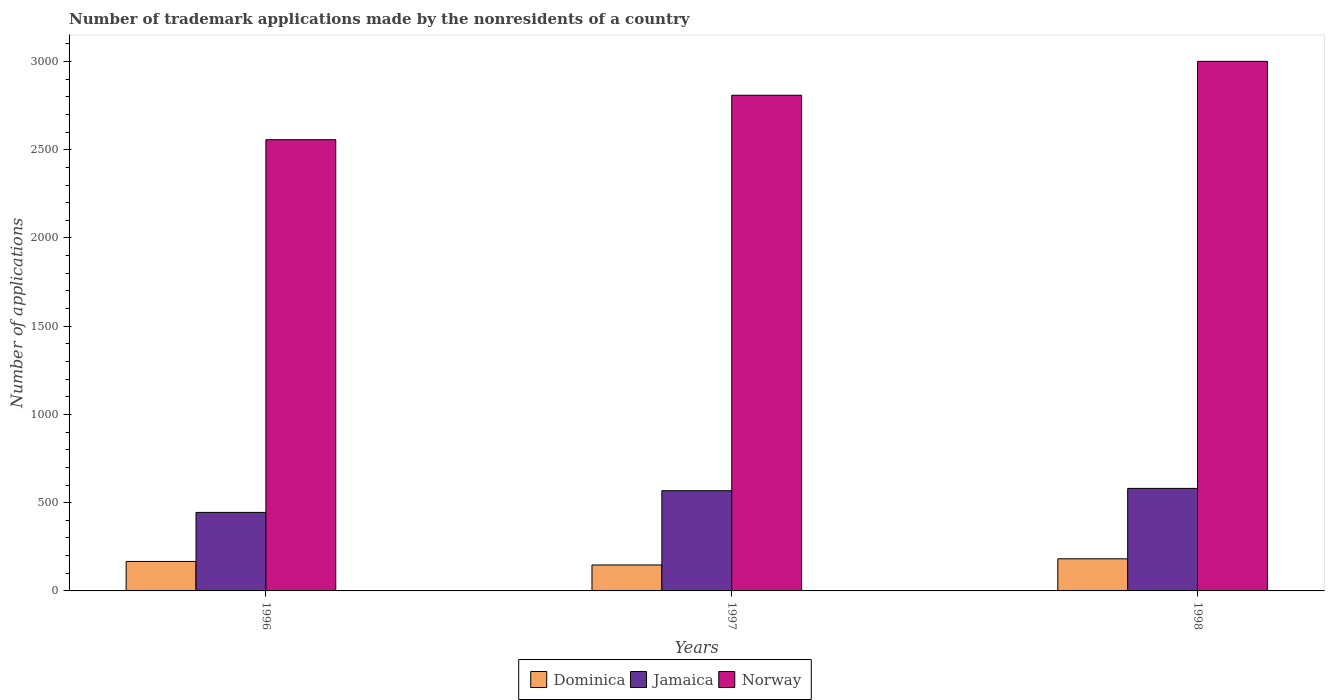How many different coloured bars are there?
Offer a terse response. 3. Are the number of bars on each tick of the X-axis equal?
Your answer should be very brief. Yes. How many bars are there on the 1st tick from the right?
Keep it short and to the point. 3. In how many cases, is the number of bars for a given year not equal to the number of legend labels?
Ensure brevity in your answer.  0. What is the number of trademark applications made by the nonresidents in Jamaica in 1996?
Offer a very short reply. 445. Across all years, what is the maximum number of trademark applications made by the nonresidents in Jamaica?
Your answer should be compact. 581. Across all years, what is the minimum number of trademark applications made by the nonresidents in Dominica?
Ensure brevity in your answer.  147. In which year was the number of trademark applications made by the nonresidents in Jamaica minimum?
Give a very brief answer. 1996. What is the total number of trademark applications made by the nonresidents in Norway in the graph?
Provide a short and direct response. 8367. What is the difference between the number of trademark applications made by the nonresidents in Norway in 1996 and that in 1997?
Offer a very short reply. -252. What is the difference between the number of trademark applications made by the nonresidents in Dominica in 1997 and the number of trademark applications made by the nonresidents in Jamaica in 1996?
Keep it short and to the point. -298. What is the average number of trademark applications made by the nonresidents in Jamaica per year?
Offer a very short reply. 531.33. In the year 1998, what is the difference between the number of trademark applications made by the nonresidents in Dominica and number of trademark applications made by the nonresidents in Jamaica?
Your answer should be compact. -399. In how many years, is the number of trademark applications made by the nonresidents in Jamaica greater than 2200?
Give a very brief answer. 0. What is the ratio of the number of trademark applications made by the nonresidents in Jamaica in 1996 to that in 1997?
Offer a very short reply. 0.78. What is the difference between the highest and the second highest number of trademark applications made by the nonresidents in Jamaica?
Provide a short and direct response. 13. What is the difference between the highest and the lowest number of trademark applications made by the nonresidents in Norway?
Make the answer very short. 444. What does the 3rd bar from the left in 1996 represents?
Offer a terse response. Norway. How many bars are there?
Your answer should be compact. 9. Are all the bars in the graph horizontal?
Provide a short and direct response. No. How many years are there in the graph?
Ensure brevity in your answer.  3. What is the difference between two consecutive major ticks on the Y-axis?
Offer a very short reply. 500. Are the values on the major ticks of Y-axis written in scientific E-notation?
Your answer should be very brief. No. Where does the legend appear in the graph?
Provide a short and direct response. Bottom center. How many legend labels are there?
Give a very brief answer. 3. What is the title of the graph?
Give a very brief answer. Number of trademark applications made by the nonresidents of a country. Does "Lesotho" appear as one of the legend labels in the graph?
Ensure brevity in your answer.  No. What is the label or title of the X-axis?
Ensure brevity in your answer.  Years. What is the label or title of the Y-axis?
Provide a short and direct response. Number of applications. What is the Number of applications of Dominica in 1996?
Your answer should be very brief. 167. What is the Number of applications in Jamaica in 1996?
Provide a succinct answer. 445. What is the Number of applications in Norway in 1996?
Your answer should be compact. 2557. What is the Number of applications of Dominica in 1997?
Give a very brief answer. 147. What is the Number of applications of Jamaica in 1997?
Offer a very short reply. 568. What is the Number of applications in Norway in 1997?
Provide a short and direct response. 2809. What is the Number of applications in Dominica in 1998?
Your response must be concise. 182. What is the Number of applications of Jamaica in 1998?
Your answer should be very brief. 581. What is the Number of applications in Norway in 1998?
Offer a terse response. 3001. Across all years, what is the maximum Number of applications of Dominica?
Keep it short and to the point. 182. Across all years, what is the maximum Number of applications of Jamaica?
Make the answer very short. 581. Across all years, what is the maximum Number of applications in Norway?
Give a very brief answer. 3001. Across all years, what is the minimum Number of applications in Dominica?
Provide a short and direct response. 147. Across all years, what is the minimum Number of applications in Jamaica?
Ensure brevity in your answer.  445. Across all years, what is the minimum Number of applications in Norway?
Your answer should be compact. 2557. What is the total Number of applications of Dominica in the graph?
Ensure brevity in your answer.  496. What is the total Number of applications in Jamaica in the graph?
Your response must be concise. 1594. What is the total Number of applications in Norway in the graph?
Your response must be concise. 8367. What is the difference between the Number of applications of Jamaica in 1996 and that in 1997?
Provide a short and direct response. -123. What is the difference between the Number of applications in Norway in 1996 and that in 1997?
Give a very brief answer. -252. What is the difference between the Number of applications in Dominica in 1996 and that in 1998?
Your response must be concise. -15. What is the difference between the Number of applications in Jamaica in 1996 and that in 1998?
Give a very brief answer. -136. What is the difference between the Number of applications of Norway in 1996 and that in 1998?
Give a very brief answer. -444. What is the difference between the Number of applications of Dominica in 1997 and that in 1998?
Give a very brief answer. -35. What is the difference between the Number of applications in Jamaica in 1997 and that in 1998?
Give a very brief answer. -13. What is the difference between the Number of applications in Norway in 1997 and that in 1998?
Ensure brevity in your answer.  -192. What is the difference between the Number of applications in Dominica in 1996 and the Number of applications in Jamaica in 1997?
Keep it short and to the point. -401. What is the difference between the Number of applications of Dominica in 1996 and the Number of applications of Norway in 1997?
Provide a short and direct response. -2642. What is the difference between the Number of applications of Jamaica in 1996 and the Number of applications of Norway in 1997?
Make the answer very short. -2364. What is the difference between the Number of applications of Dominica in 1996 and the Number of applications of Jamaica in 1998?
Provide a succinct answer. -414. What is the difference between the Number of applications in Dominica in 1996 and the Number of applications in Norway in 1998?
Your answer should be very brief. -2834. What is the difference between the Number of applications of Jamaica in 1996 and the Number of applications of Norway in 1998?
Offer a very short reply. -2556. What is the difference between the Number of applications in Dominica in 1997 and the Number of applications in Jamaica in 1998?
Ensure brevity in your answer.  -434. What is the difference between the Number of applications in Dominica in 1997 and the Number of applications in Norway in 1998?
Offer a very short reply. -2854. What is the difference between the Number of applications of Jamaica in 1997 and the Number of applications of Norway in 1998?
Your answer should be compact. -2433. What is the average Number of applications in Dominica per year?
Provide a short and direct response. 165.33. What is the average Number of applications in Jamaica per year?
Give a very brief answer. 531.33. What is the average Number of applications in Norway per year?
Ensure brevity in your answer.  2789. In the year 1996, what is the difference between the Number of applications in Dominica and Number of applications in Jamaica?
Make the answer very short. -278. In the year 1996, what is the difference between the Number of applications in Dominica and Number of applications in Norway?
Provide a succinct answer. -2390. In the year 1996, what is the difference between the Number of applications in Jamaica and Number of applications in Norway?
Ensure brevity in your answer.  -2112. In the year 1997, what is the difference between the Number of applications of Dominica and Number of applications of Jamaica?
Keep it short and to the point. -421. In the year 1997, what is the difference between the Number of applications in Dominica and Number of applications in Norway?
Your answer should be very brief. -2662. In the year 1997, what is the difference between the Number of applications of Jamaica and Number of applications of Norway?
Make the answer very short. -2241. In the year 1998, what is the difference between the Number of applications of Dominica and Number of applications of Jamaica?
Provide a succinct answer. -399. In the year 1998, what is the difference between the Number of applications in Dominica and Number of applications in Norway?
Your answer should be compact. -2819. In the year 1998, what is the difference between the Number of applications of Jamaica and Number of applications of Norway?
Your answer should be very brief. -2420. What is the ratio of the Number of applications in Dominica in 1996 to that in 1997?
Ensure brevity in your answer.  1.14. What is the ratio of the Number of applications of Jamaica in 1996 to that in 1997?
Your response must be concise. 0.78. What is the ratio of the Number of applications of Norway in 1996 to that in 1997?
Your answer should be very brief. 0.91. What is the ratio of the Number of applications in Dominica in 1996 to that in 1998?
Provide a succinct answer. 0.92. What is the ratio of the Number of applications in Jamaica in 1996 to that in 1998?
Your answer should be compact. 0.77. What is the ratio of the Number of applications of Norway in 1996 to that in 1998?
Offer a terse response. 0.85. What is the ratio of the Number of applications in Dominica in 1997 to that in 1998?
Ensure brevity in your answer.  0.81. What is the ratio of the Number of applications in Jamaica in 1997 to that in 1998?
Provide a short and direct response. 0.98. What is the ratio of the Number of applications of Norway in 1997 to that in 1998?
Provide a succinct answer. 0.94. What is the difference between the highest and the second highest Number of applications in Jamaica?
Give a very brief answer. 13. What is the difference between the highest and the second highest Number of applications in Norway?
Offer a terse response. 192. What is the difference between the highest and the lowest Number of applications in Jamaica?
Your answer should be very brief. 136. What is the difference between the highest and the lowest Number of applications of Norway?
Keep it short and to the point. 444. 